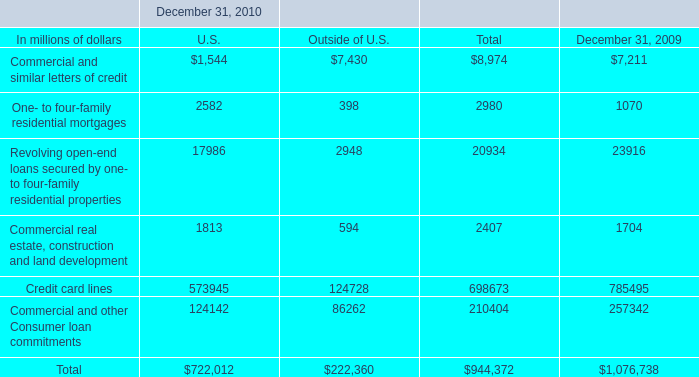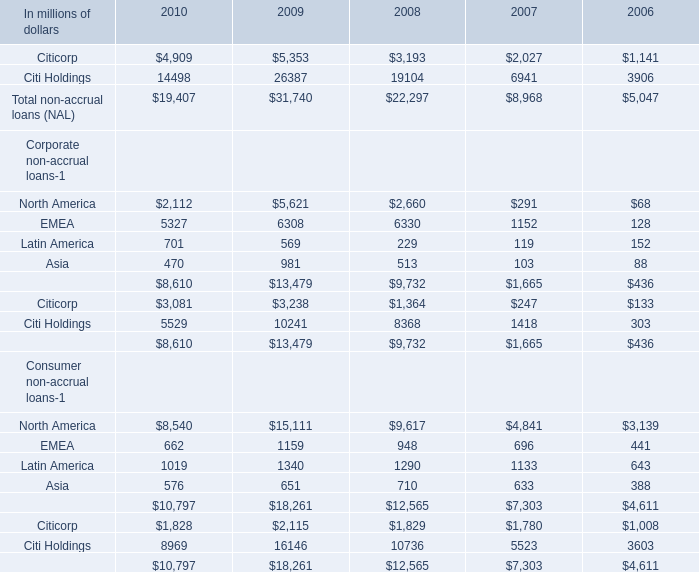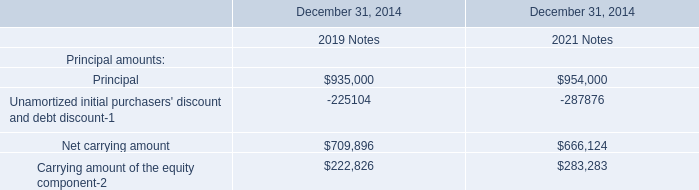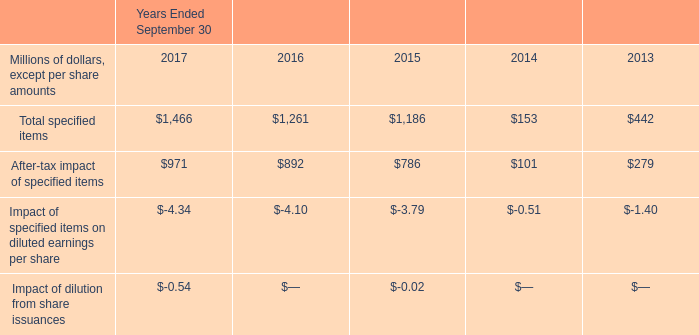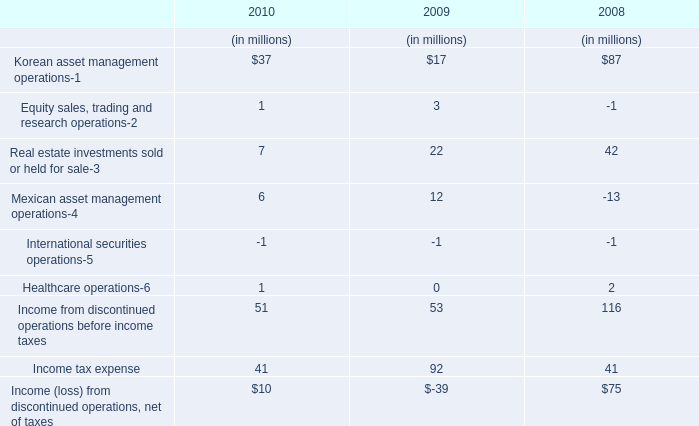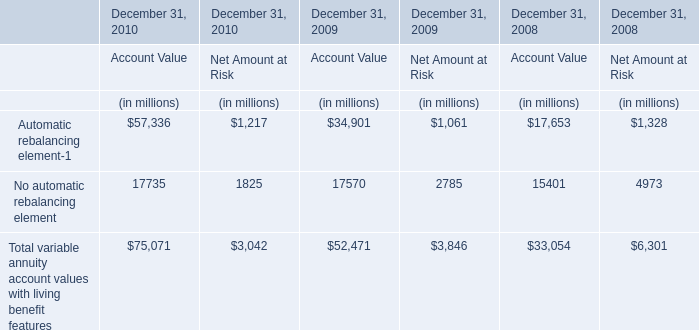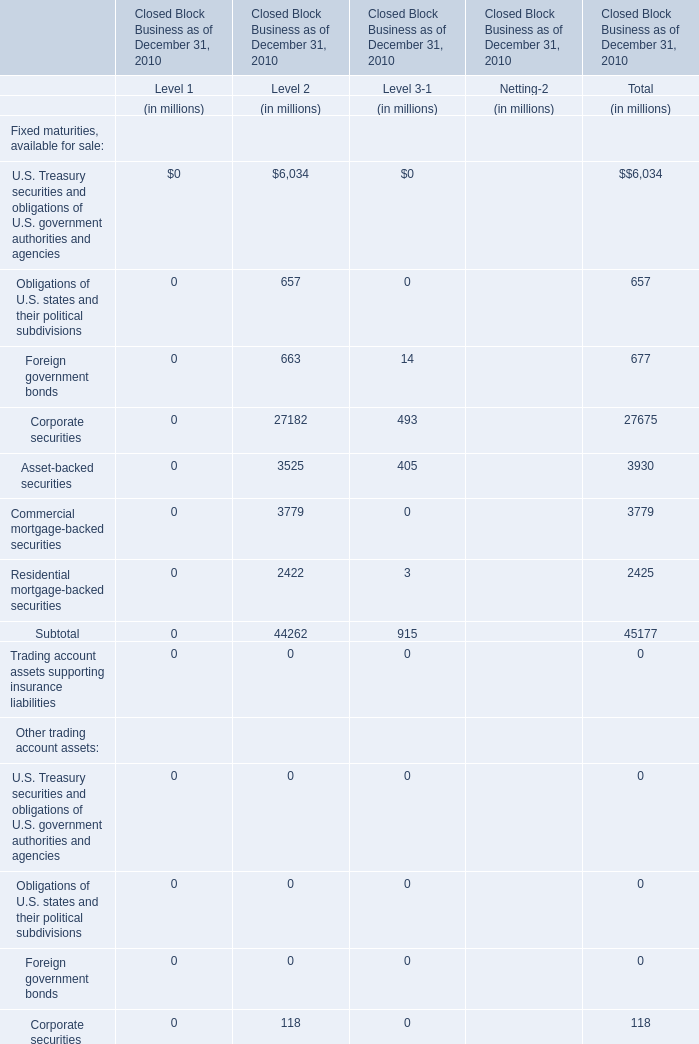What is the growing rate of Corporate non-accrual loans in the year with the most total non-accrual loans (NAL)? 
Computations: ((8610 - 13479) / 13479)
Answer: -0.36123. 